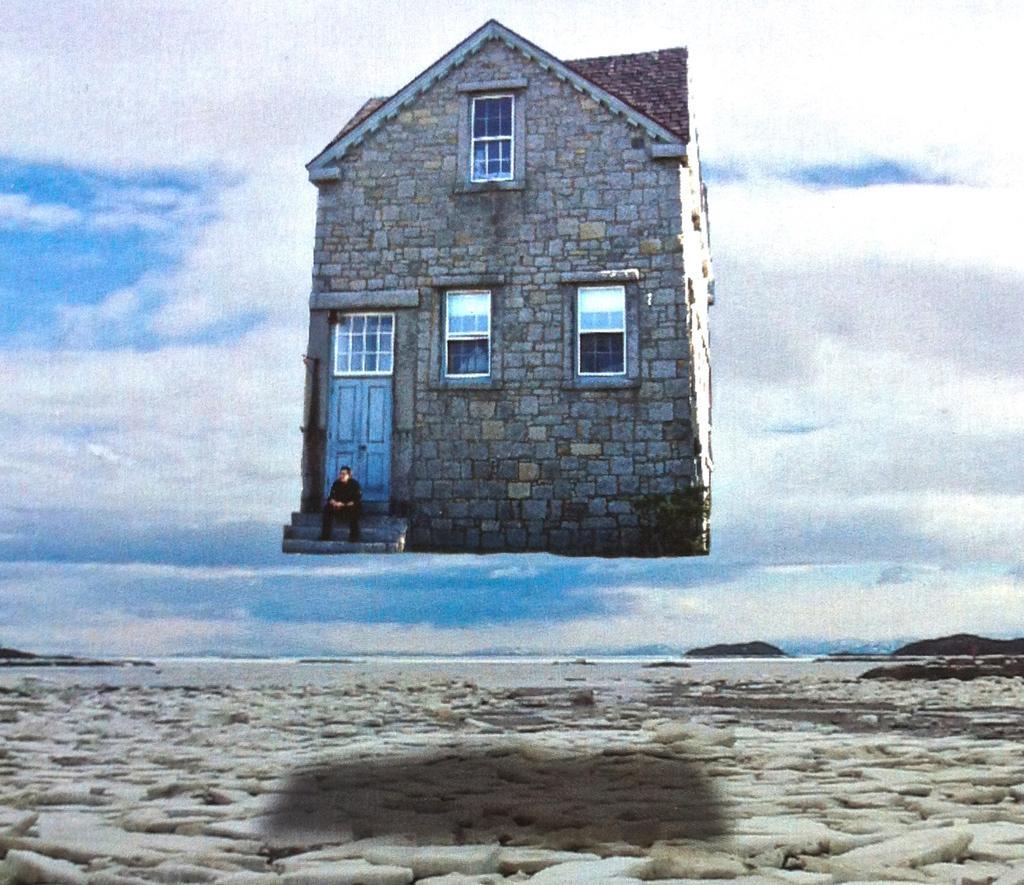In one or two sentences, can you explain what this image depicts? It is an edited image. In this image we can see a house with a door and windows. We can also see a person sitting on the stairs. In the background there is sky with the clouds and at the bottom we can see the stones. 